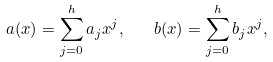Convert formula to latex. <formula><loc_0><loc_0><loc_500><loc_500>a ( x ) = \sum _ { j = 0 } ^ { h } a _ { j } x ^ { j } , \quad b ( x ) = \sum _ { j = 0 } ^ { h } b _ { j } x ^ { j } ,</formula> 